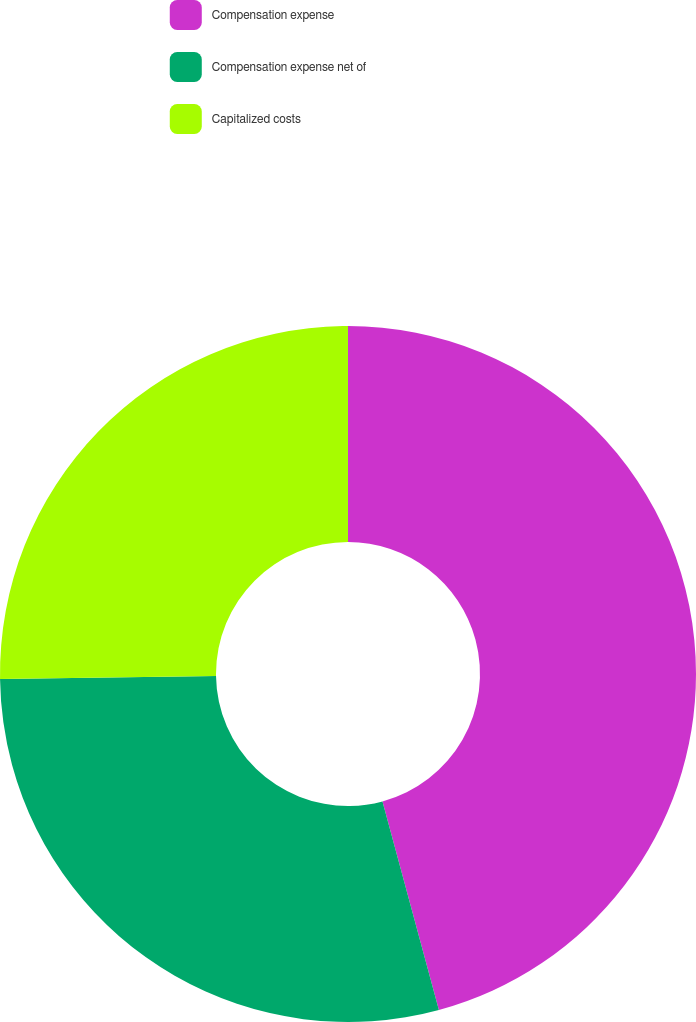Convert chart. <chart><loc_0><loc_0><loc_500><loc_500><pie_chart><fcel>Compensation expense<fcel>Compensation expense net of<fcel>Capitalized costs<nl><fcel>45.79%<fcel>28.97%<fcel>25.23%<nl></chart> 